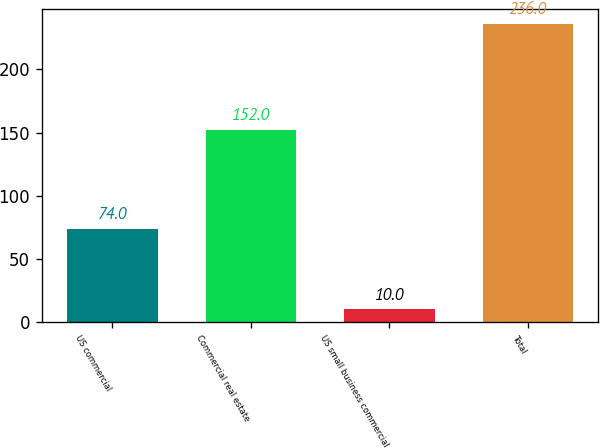Convert chart. <chart><loc_0><loc_0><loc_500><loc_500><bar_chart><fcel>US commercial<fcel>Commercial real estate<fcel>US small business commercial<fcel>Total<nl><fcel>74<fcel>152<fcel>10<fcel>236<nl></chart> 